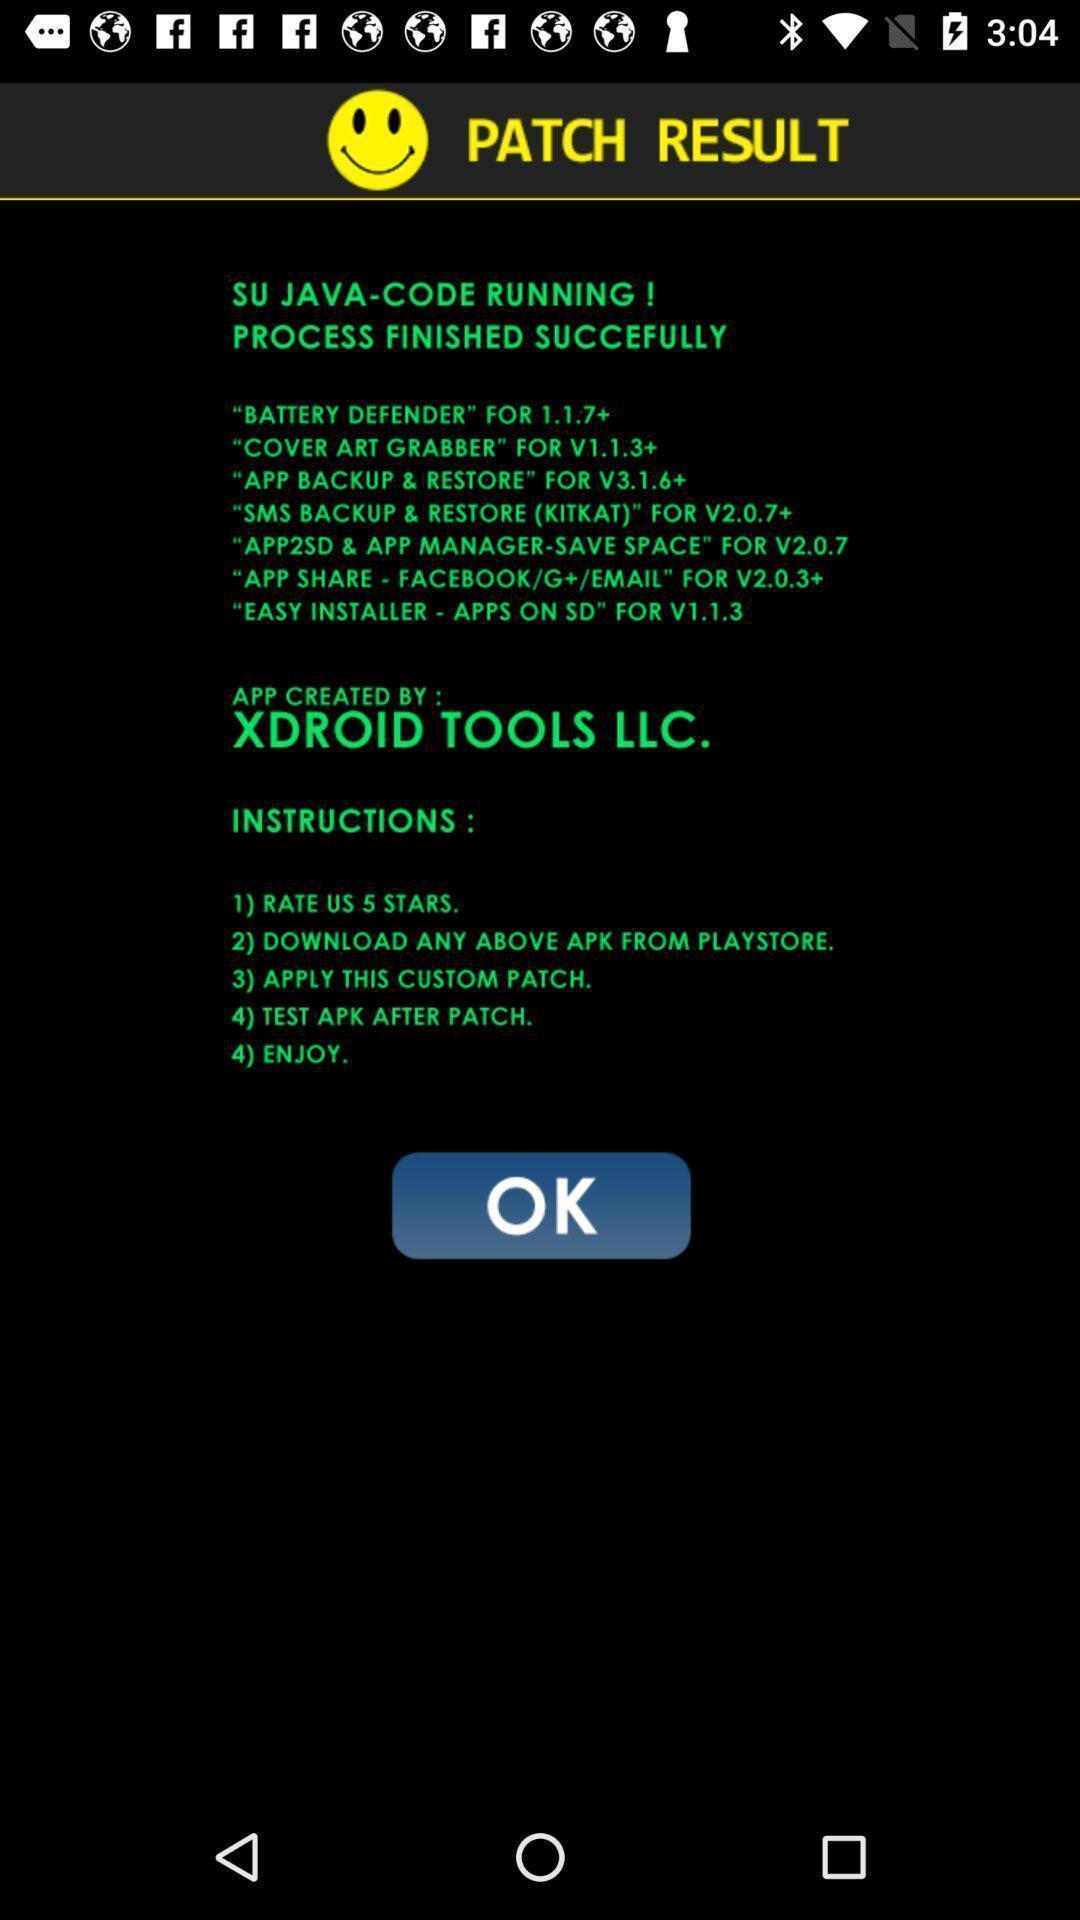Give me a summary of this screen capture. Screen displaying the results page. 